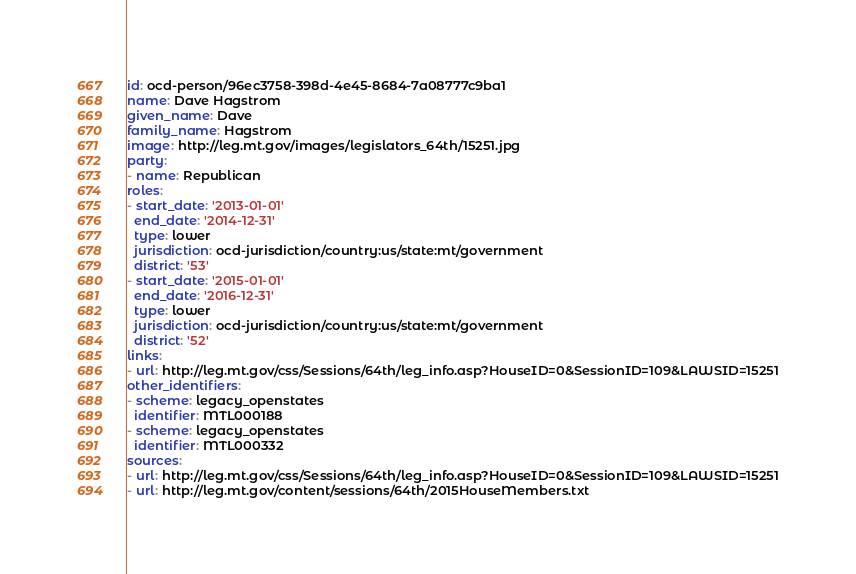<code> <loc_0><loc_0><loc_500><loc_500><_YAML_>id: ocd-person/96ec3758-398d-4e45-8684-7a08777c9ba1
name: Dave Hagstrom
given_name: Dave
family_name: Hagstrom
image: http://leg.mt.gov/images/legislators_64th/15251.jpg
party:
- name: Republican
roles:
- start_date: '2013-01-01'
  end_date: '2014-12-31'
  type: lower
  jurisdiction: ocd-jurisdiction/country:us/state:mt/government
  district: '53'
- start_date: '2015-01-01'
  end_date: '2016-12-31'
  type: lower
  jurisdiction: ocd-jurisdiction/country:us/state:mt/government
  district: '52'
links:
- url: http://leg.mt.gov/css/Sessions/64th/leg_info.asp?HouseID=0&SessionID=109&LAWSID=15251
other_identifiers:
- scheme: legacy_openstates
  identifier: MTL000188
- scheme: legacy_openstates
  identifier: MTL000332
sources:
- url: http://leg.mt.gov/css/Sessions/64th/leg_info.asp?HouseID=0&SessionID=109&LAWSID=15251
- url: http://leg.mt.gov/content/sessions/64th/2015HouseMembers.txt
</code> 